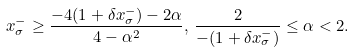Convert formula to latex. <formula><loc_0><loc_0><loc_500><loc_500>x _ { \sigma } ^ { - } \geq \frac { - 4 ( 1 + \delta x _ { \sigma } ^ { - } ) - 2 \alpha } { 4 - \alpha ^ { 2 } } , \, \frac { 2 } { - ( 1 + \delta x _ { \sigma } ^ { - } ) } \leq \alpha < 2 .</formula> 